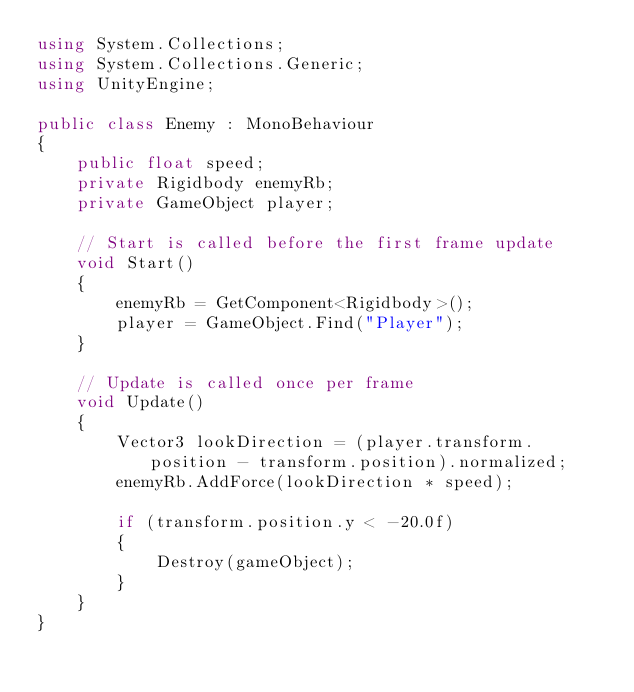Convert code to text. <code><loc_0><loc_0><loc_500><loc_500><_C#_>using System.Collections;
using System.Collections.Generic;
using UnityEngine;

public class Enemy : MonoBehaviour
{
    public float speed;
    private Rigidbody enemyRb;
    private GameObject player;

    // Start is called before the first frame update
    void Start()
    {
        enemyRb = GetComponent<Rigidbody>();
        player = GameObject.Find("Player");
    }

    // Update is called once per frame
    void Update()
    {
        Vector3 lookDirection = (player.transform.position - transform.position).normalized;
        enemyRb.AddForce(lookDirection * speed);

        if (transform.position.y < -20.0f)
        {
            Destroy(gameObject);
        }
    }
}
</code> 